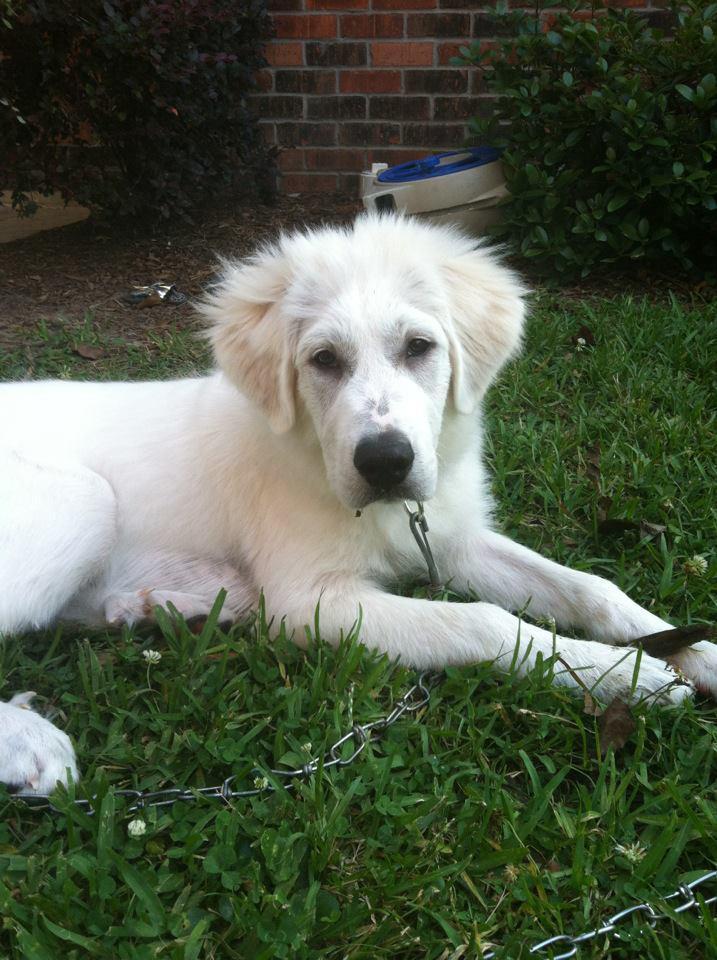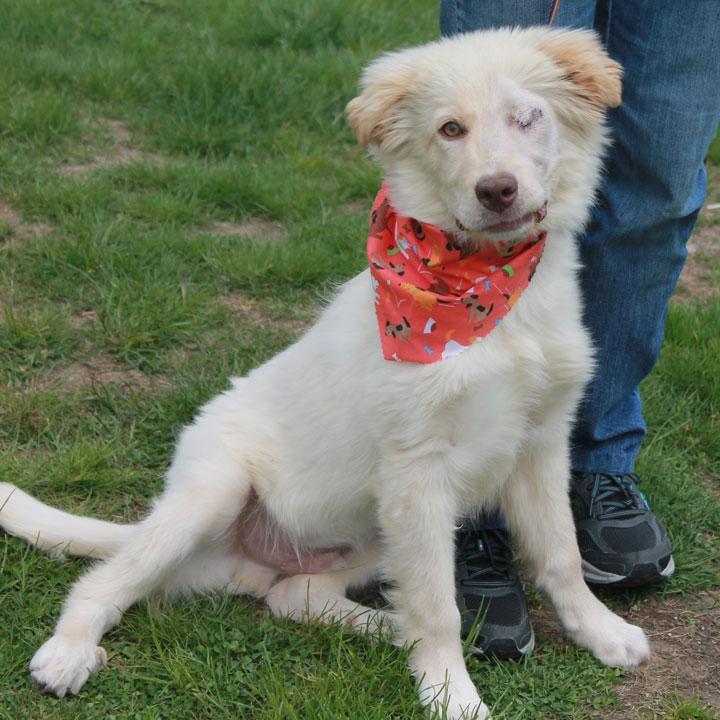The first image is the image on the left, the second image is the image on the right. For the images displayed, is the sentence "There is a white dog in each photo looking straight ahead enjoying it's time outside." factually correct? Answer yes or no. Yes. The first image is the image on the left, the second image is the image on the right. Assess this claim about the two images: "in both pairs the dogs are on a natural outdoor surface". Correct or not? Answer yes or no. Yes. 